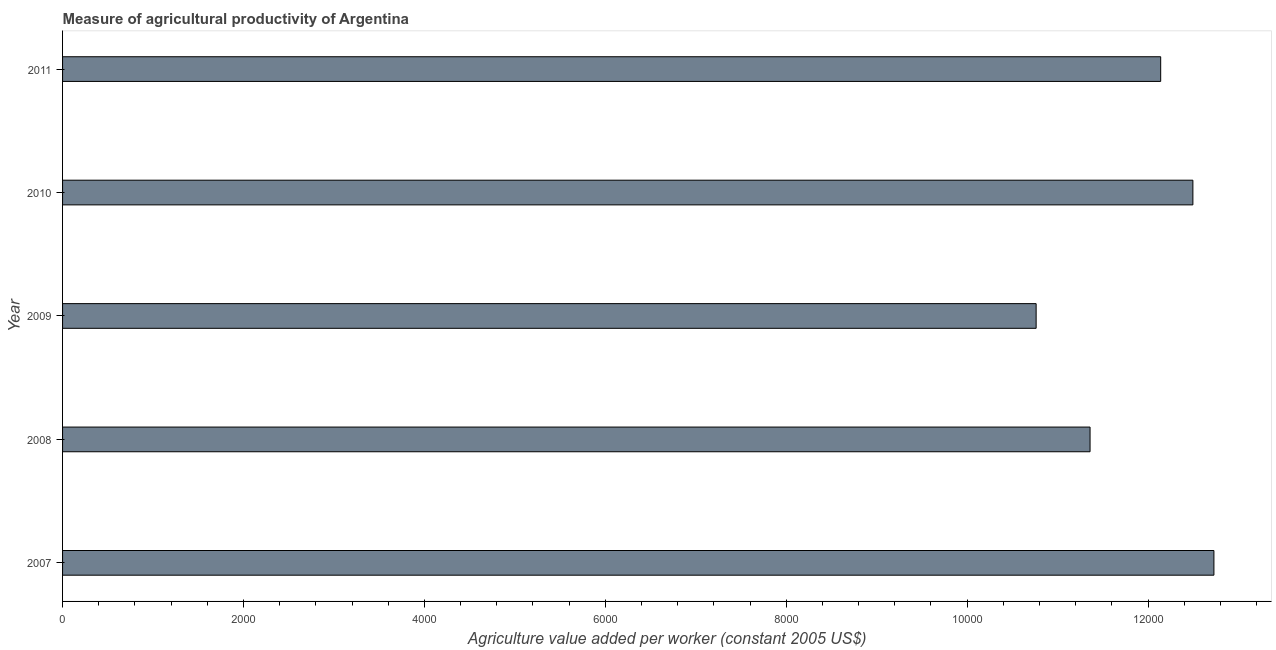What is the title of the graph?
Make the answer very short. Measure of agricultural productivity of Argentina. What is the label or title of the X-axis?
Give a very brief answer. Agriculture value added per worker (constant 2005 US$). What is the label or title of the Y-axis?
Offer a terse response. Year. What is the agriculture value added per worker in 2009?
Give a very brief answer. 1.08e+04. Across all years, what is the maximum agriculture value added per worker?
Your response must be concise. 1.27e+04. Across all years, what is the minimum agriculture value added per worker?
Ensure brevity in your answer.  1.08e+04. What is the sum of the agriculture value added per worker?
Offer a very short reply. 5.95e+04. What is the difference between the agriculture value added per worker in 2007 and 2011?
Keep it short and to the point. 588.46. What is the average agriculture value added per worker per year?
Offer a very short reply. 1.19e+04. What is the median agriculture value added per worker?
Keep it short and to the point. 1.21e+04. In how many years, is the agriculture value added per worker greater than 8800 US$?
Your answer should be very brief. 5. What is the ratio of the agriculture value added per worker in 2007 to that in 2009?
Offer a very short reply. 1.18. Is the difference between the agriculture value added per worker in 2008 and 2009 greater than the difference between any two years?
Keep it short and to the point. No. What is the difference between the highest and the second highest agriculture value added per worker?
Make the answer very short. 232.52. Is the sum of the agriculture value added per worker in 2008 and 2009 greater than the maximum agriculture value added per worker across all years?
Your answer should be very brief. Yes. What is the difference between the highest and the lowest agriculture value added per worker?
Offer a very short reply. 1965.46. Are all the bars in the graph horizontal?
Your answer should be compact. Yes. What is the difference between two consecutive major ticks on the X-axis?
Offer a very short reply. 2000. Are the values on the major ticks of X-axis written in scientific E-notation?
Make the answer very short. No. What is the Agriculture value added per worker (constant 2005 US$) of 2007?
Offer a terse response. 1.27e+04. What is the Agriculture value added per worker (constant 2005 US$) in 2008?
Your answer should be very brief. 1.14e+04. What is the Agriculture value added per worker (constant 2005 US$) in 2009?
Your response must be concise. 1.08e+04. What is the Agriculture value added per worker (constant 2005 US$) in 2010?
Keep it short and to the point. 1.25e+04. What is the Agriculture value added per worker (constant 2005 US$) in 2011?
Offer a very short reply. 1.21e+04. What is the difference between the Agriculture value added per worker (constant 2005 US$) in 2007 and 2008?
Your answer should be compact. 1369.31. What is the difference between the Agriculture value added per worker (constant 2005 US$) in 2007 and 2009?
Offer a terse response. 1965.46. What is the difference between the Agriculture value added per worker (constant 2005 US$) in 2007 and 2010?
Ensure brevity in your answer.  232.52. What is the difference between the Agriculture value added per worker (constant 2005 US$) in 2007 and 2011?
Give a very brief answer. 588.46. What is the difference between the Agriculture value added per worker (constant 2005 US$) in 2008 and 2009?
Give a very brief answer. 596.16. What is the difference between the Agriculture value added per worker (constant 2005 US$) in 2008 and 2010?
Your response must be concise. -1136.79. What is the difference between the Agriculture value added per worker (constant 2005 US$) in 2008 and 2011?
Offer a very short reply. -780.84. What is the difference between the Agriculture value added per worker (constant 2005 US$) in 2009 and 2010?
Your answer should be compact. -1732.95. What is the difference between the Agriculture value added per worker (constant 2005 US$) in 2009 and 2011?
Your answer should be compact. -1377. What is the difference between the Agriculture value added per worker (constant 2005 US$) in 2010 and 2011?
Give a very brief answer. 355.95. What is the ratio of the Agriculture value added per worker (constant 2005 US$) in 2007 to that in 2008?
Your answer should be compact. 1.12. What is the ratio of the Agriculture value added per worker (constant 2005 US$) in 2007 to that in 2009?
Ensure brevity in your answer.  1.18. What is the ratio of the Agriculture value added per worker (constant 2005 US$) in 2007 to that in 2010?
Ensure brevity in your answer.  1.02. What is the ratio of the Agriculture value added per worker (constant 2005 US$) in 2007 to that in 2011?
Offer a terse response. 1.05. What is the ratio of the Agriculture value added per worker (constant 2005 US$) in 2008 to that in 2009?
Keep it short and to the point. 1.05. What is the ratio of the Agriculture value added per worker (constant 2005 US$) in 2008 to that in 2010?
Keep it short and to the point. 0.91. What is the ratio of the Agriculture value added per worker (constant 2005 US$) in 2008 to that in 2011?
Your answer should be very brief. 0.94. What is the ratio of the Agriculture value added per worker (constant 2005 US$) in 2009 to that in 2010?
Offer a very short reply. 0.86. What is the ratio of the Agriculture value added per worker (constant 2005 US$) in 2009 to that in 2011?
Provide a short and direct response. 0.89. 